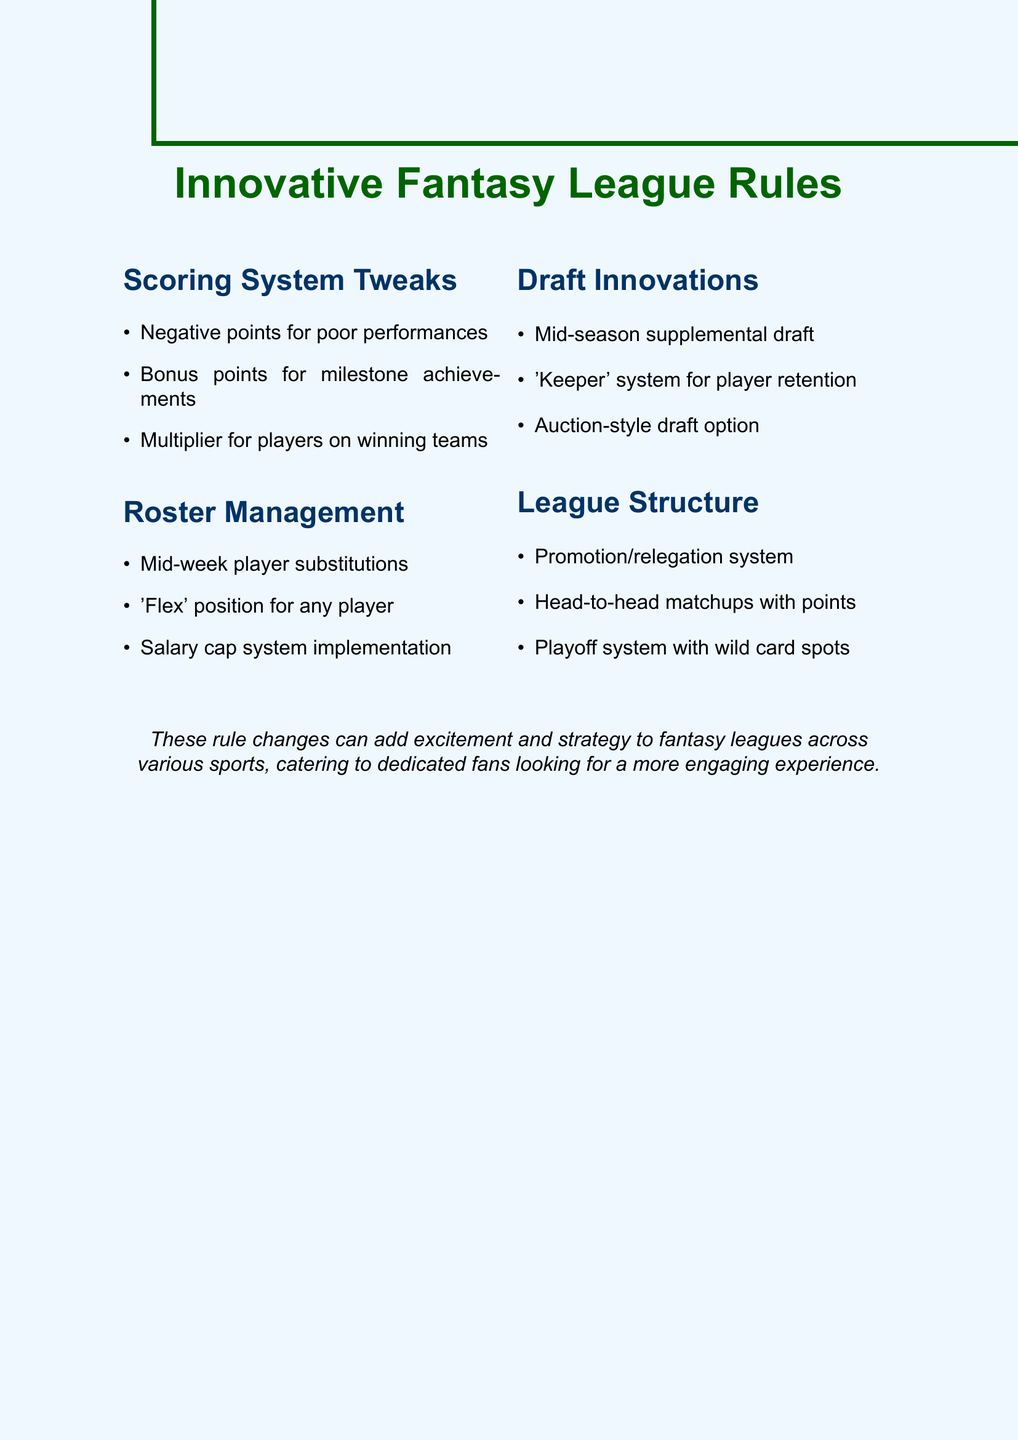what is the main topic of the document? The document discusses innovative ideas for creating fantasy league rules to enhance the game experience for sports enthusiasts.
Answer: innovative fantasy league rules how many sections are in the document? The document features four distinct sections outlining various rule changes.
Answer: four what is one proposed tweak to the scoring system? The section on scoring system tweaks includes several suggestions for enhancing the scoring in fantasy leagues.
Answer: negative points for poor performances what does the roster management section suggest about player substitutions? The roster management section discusses various strategies for managing players in fantasy leagues.
Answer: mid-week player substitutions what type of draft is suggested as an alternative to the traditional snake draft? The document includes multiple draft innovations to refresh the drafting process in fantasy leagues.
Answer: auction-style draft how many points are awarded for a 100 or more rushing yards in a game? The bonus points for milestone achievements are part of the scoring system tweaks section.
Answer: five which section discusses a system for player retention? The draft innovations section outlines various strategies for improving the draft experience in fantasy leagues.
Answer: 'keeper' system for player retention what league structure innovation includes multiple tiers? The document proposes several structural changes to improve league competitiveness.
Answer: promotion/relegation system how does the playoff system enhance competitiveness? The document offers several suggestions for increasing engagement and excitement in fantasy leagues.
Answer: wild card spots 